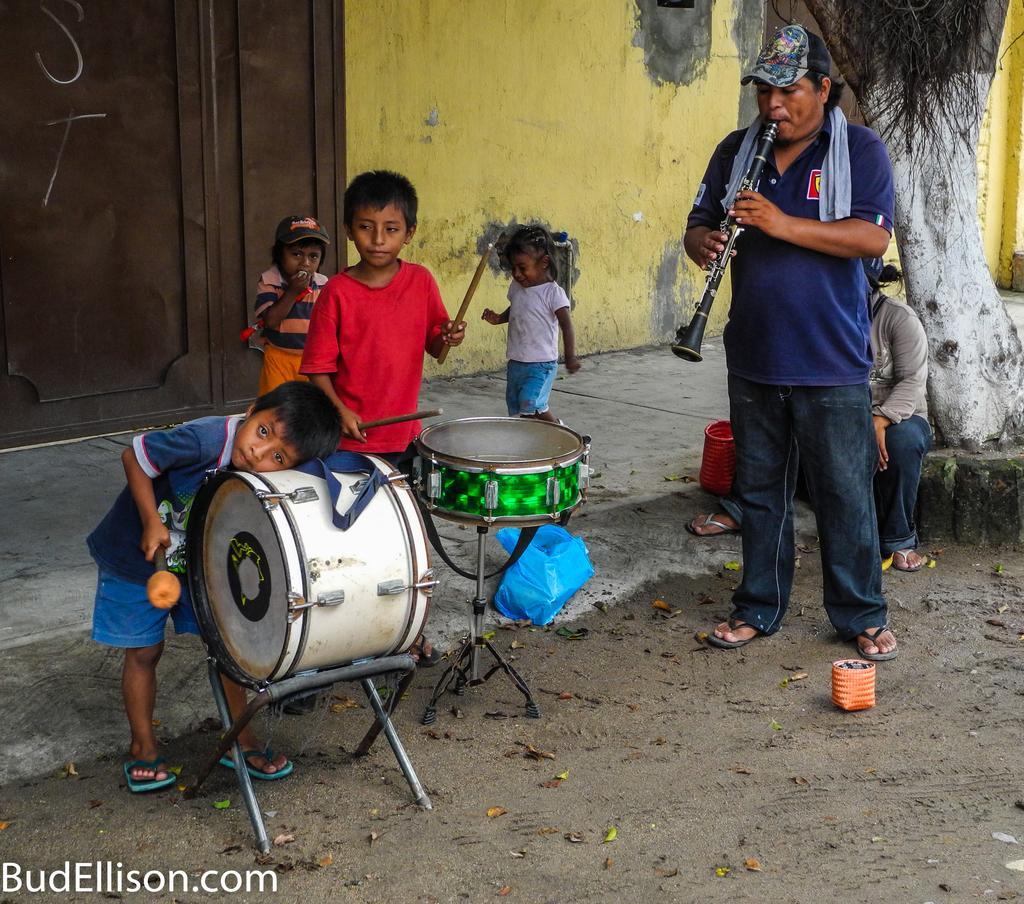How would you summarize this image in a sentence or two? The person wearing blue shirt is playing oboe and there are two kids near the drums and two kids behind them. 